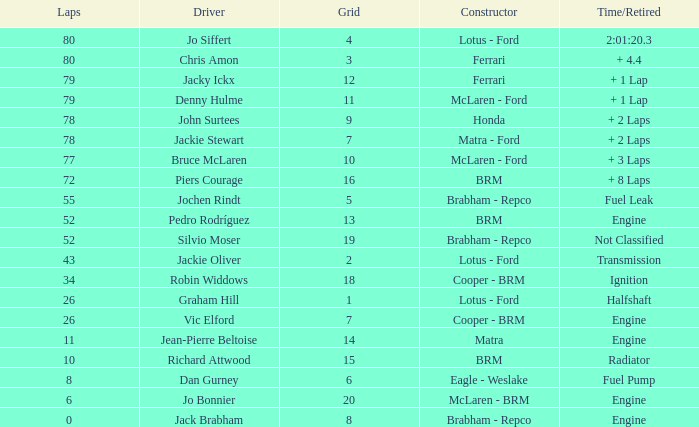Which driver possesses a grid exceeding 19? Jo Bonnier. Could you help me parse every detail presented in this table? {'header': ['Laps', 'Driver', 'Grid', 'Constructor', 'Time/Retired'], 'rows': [['80', 'Jo Siffert', '4', 'Lotus - Ford', '2:01:20.3'], ['80', 'Chris Amon', '3', 'Ferrari', '+ 4.4'], ['79', 'Jacky Ickx', '12', 'Ferrari', '+ 1 Lap'], ['79', 'Denny Hulme', '11', 'McLaren - Ford', '+ 1 Lap'], ['78', 'John Surtees', '9', 'Honda', '+ 2 Laps'], ['78', 'Jackie Stewart', '7', 'Matra - Ford', '+ 2 Laps'], ['77', 'Bruce McLaren', '10', 'McLaren - Ford', '+ 3 Laps'], ['72', 'Piers Courage', '16', 'BRM', '+ 8 Laps'], ['55', 'Jochen Rindt', '5', 'Brabham - Repco', 'Fuel Leak'], ['52', 'Pedro Rodríguez', '13', 'BRM', 'Engine'], ['52', 'Silvio Moser', '19', 'Brabham - Repco', 'Not Classified'], ['43', 'Jackie Oliver', '2', 'Lotus - Ford', 'Transmission'], ['34', 'Robin Widdows', '18', 'Cooper - BRM', 'Ignition'], ['26', 'Graham Hill', '1', 'Lotus - Ford', 'Halfshaft'], ['26', 'Vic Elford', '7', 'Cooper - BRM', 'Engine'], ['11', 'Jean-Pierre Beltoise', '14', 'Matra', 'Engine'], ['10', 'Richard Attwood', '15', 'BRM', 'Radiator'], ['8', 'Dan Gurney', '6', 'Eagle - Weslake', 'Fuel Pump'], ['6', 'Jo Bonnier', '20', 'McLaren - BRM', 'Engine'], ['0', 'Jack Brabham', '8', 'Brabham - Repco', 'Engine']]} 